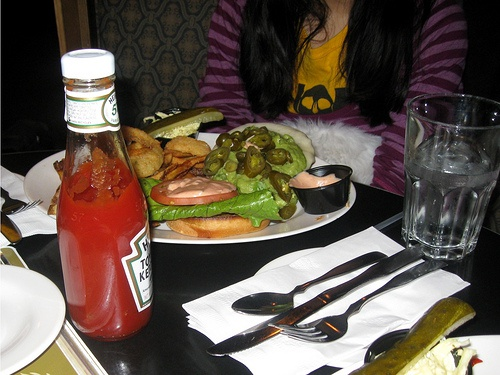Describe the objects in this image and their specific colors. I can see dining table in gray, black, white, and darkgray tones, people in gray, black, purple, darkgray, and maroon tones, bottle in gray, brown, white, and maroon tones, cup in gray, black, and darkgray tones, and sandwich in gray, olive, and black tones in this image. 